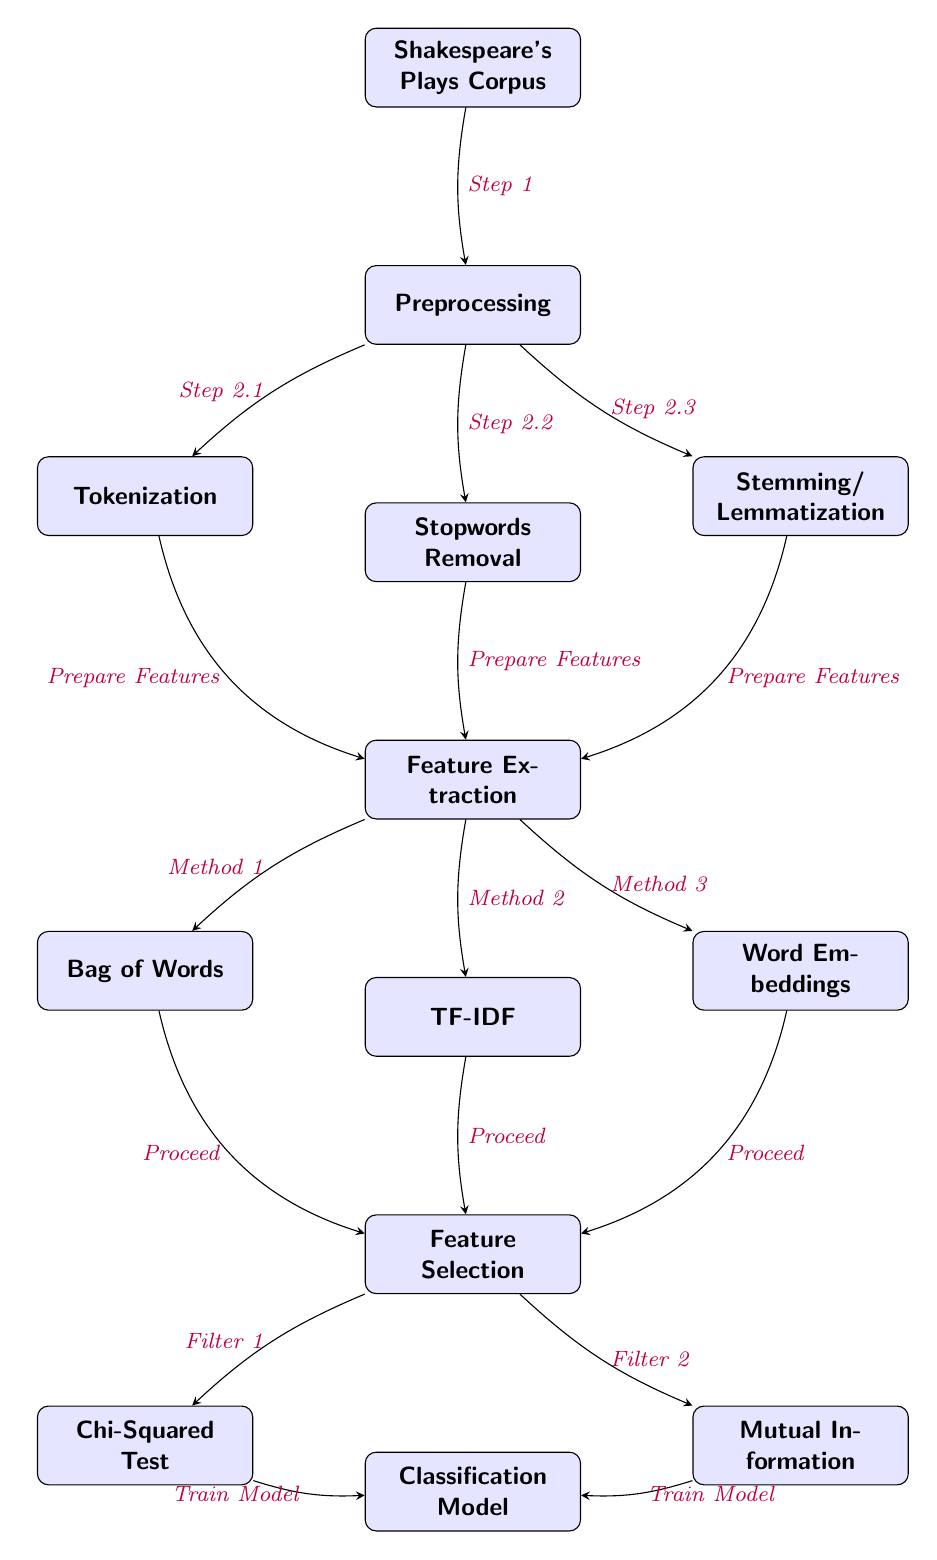What is the starting point of the feature extraction process? The starting point is the "Shakespeare's Plays Corpus" node, from which the entire process begins.
Answer: Shakespeare's Plays Corpus How many main steps are involved in the preprocessing phase? The preprocessing phase contains three main steps: Tokenization, Stopwords Removal, and Stemming/Lemmatization. Each of these steps is represented as a node below the preprocessing node.
Answer: 3 What methods follow the feature extraction node? The feature extraction node is followed by three methods: Bag of Words, TF-IDF, and Word Embeddings. These methods demonstrate different techniques for extracting features from the text data.
Answer: Bag of Words, TF-IDF, Word Embeddings Which two techniques are used for feature selection? In the feature selection phase, the two techniques used are Chi-Squared Test and Mutual Information. Both techniques aim to filter selected features based on statistical metrics.
Answer: Chi-Squared Test, Mutual Information What is the final step in the diagram after feature selection? After the feature selection process, the final step in the diagram is the "Classification Model," where the selected features are used to train a model for classifying Shakespeare's plays.
Answer: Classification Model What do the edges from the preprocessing node to feature extraction indicate? The edges from the preprocessing node to the feature extraction node indicate that all preprocessing steps (Tokenization, Stopwords Removal, Stemming/Lemmatization) contribute to preparing the text features for extraction.
Answer: Prepare Features Which method is used as "Method 2" in feature extraction? Method 2 in the feature extraction phase refers to the TF-IDF method, which is commonly used to evaluate how important a word is to a document in a corpus.
Answer: TF-IDF How do Chi-Squared Test and Mutual Information relate to the classification model? Both Chi-Squared Test and Mutual Information nodes provide filtered features that are then used to train the Classification Model, indicating their significance in the feature selection process.
Answer: Train Model 